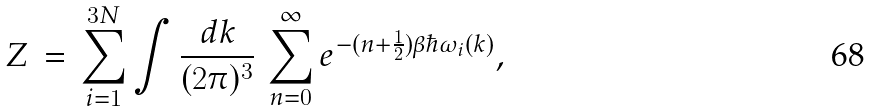<formula> <loc_0><loc_0><loc_500><loc_500>Z \, = \, \sum _ { i = 1 } ^ { 3 N } \int \frac { d { k } } { ( 2 \pi ) ^ { 3 } } \, \sum _ { n = 0 } ^ { \infty } e ^ { - ( n + \frac { 1 } { 2 } ) \beta \hbar { \omega } _ { i } ( { k } ) } ,</formula> 